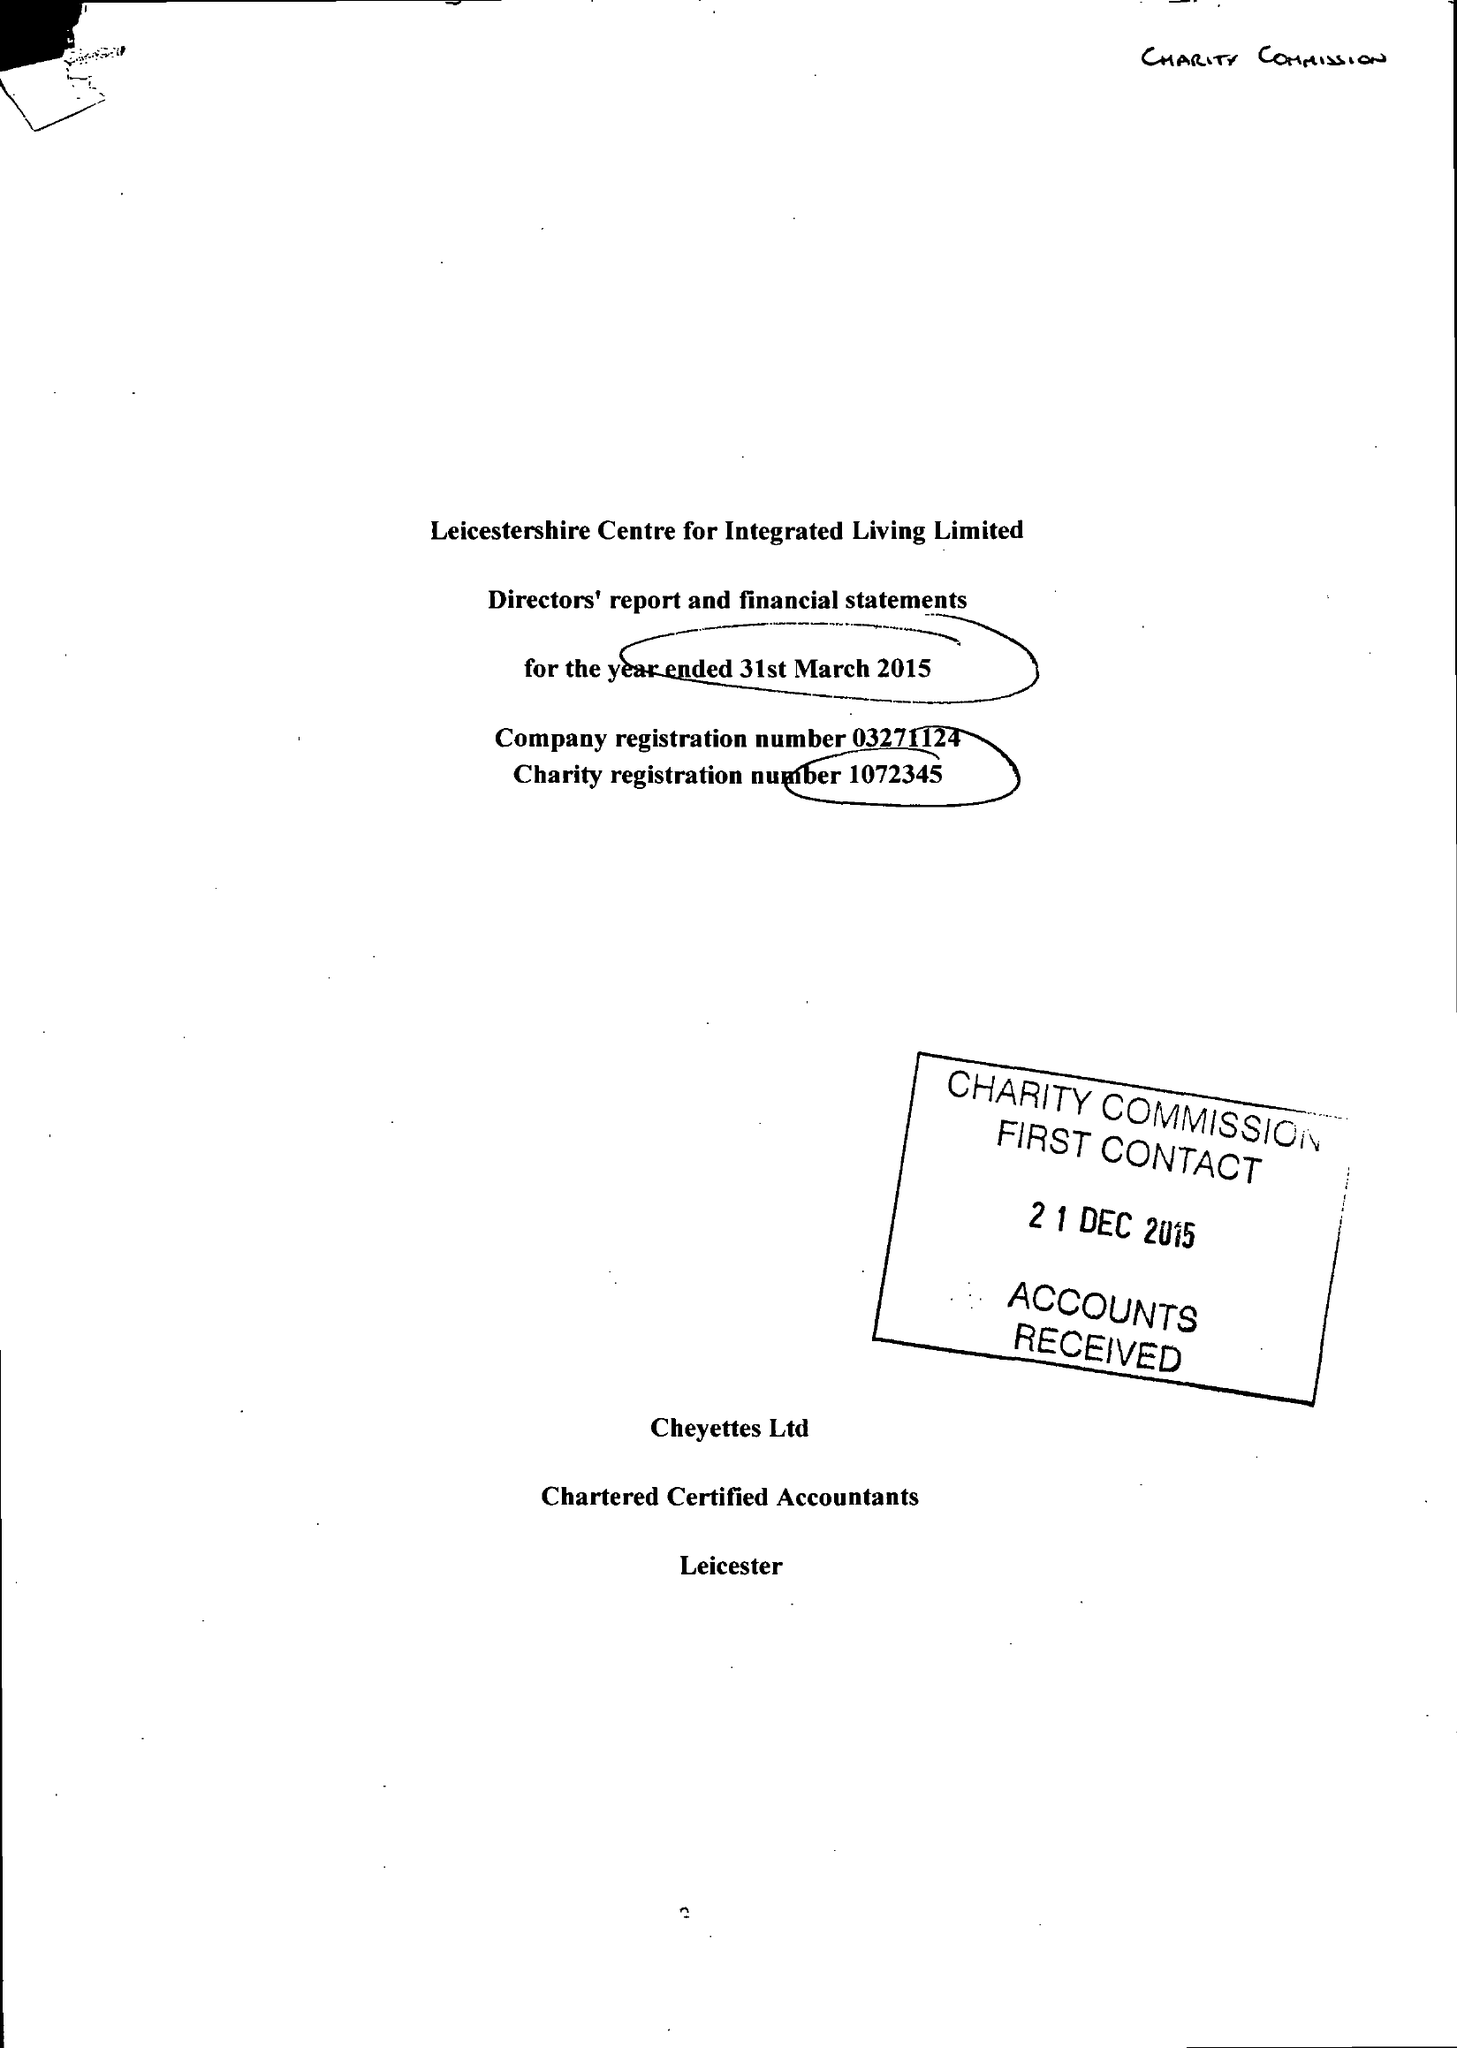What is the value for the address__post_town?
Answer the question using a single word or phrase. LEICESTER 